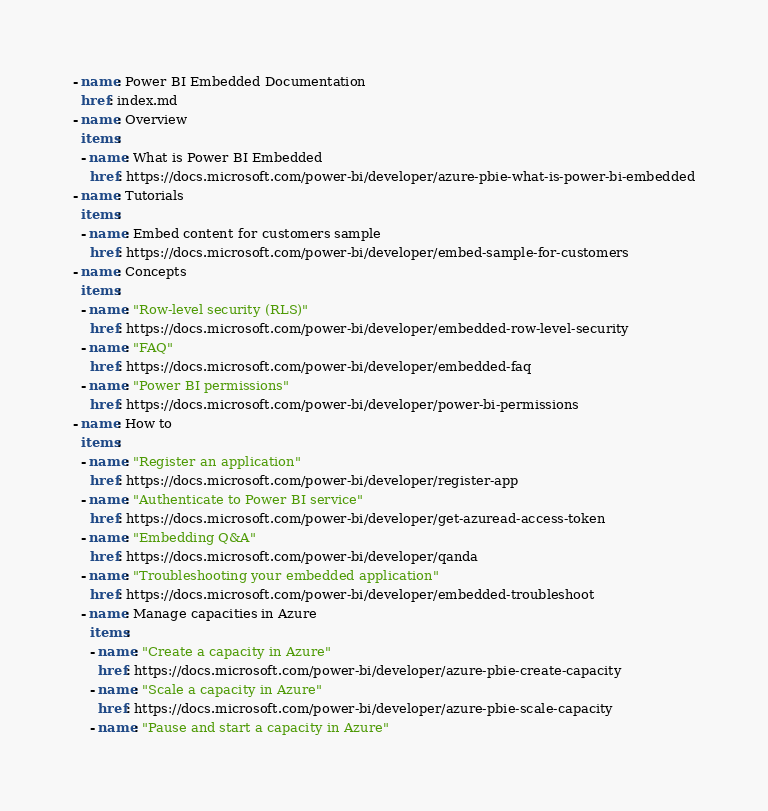Convert code to text. <code><loc_0><loc_0><loc_500><loc_500><_YAML_>- name: Power BI Embedded Documentation
  href: index.md
- name: Overview
  items:
  - name: What is Power BI Embedded
    href: https://docs.microsoft.com/power-bi/developer/azure-pbie-what-is-power-bi-embedded
- name: Tutorials
  items:
  - name: Embed content for customers sample
    href: https://docs.microsoft.com/power-bi/developer/embed-sample-for-customers
- name: Concepts
  items:
  - name: "Row-level security (RLS)"
    href: https://docs.microsoft.com/power-bi/developer/embedded-row-level-security
  - name: "FAQ"
    href: https://docs.microsoft.com/power-bi/developer/embedded-faq
  - name: "Power BI permissions"
    href: https://docs.microsoft.com/power-bi/developer/power-bi-permissions
- name: How to
  items: 
  - name: "Register an application"
    href: https://docs.microsoft.com/power-bi/developer/register-app
  - name: "Authenticate to Power BI service"
    href: https://docs.microsoft.com/power-bi/developer/get-azuread-access-token
  - name: "Embedding Q&A"
    href: https://docs.microsoft.com/power-bi/developer/qanda
  - name: "Troubleshooting your embedded application"
    href: https://docs.microsoft.com/power-bi/developer/embedded-troubleshoot
  - name: Manage capacities in Azure
    items:
    - name: "Create a capacity in Azure"
      href: https://docs.microsoft.com/power-bi/developer/azure-pbie-create-capacity
    - name: "Scale a capacity in Azure"
      href: https://docs.microsoft.com/power-bi/developer/azure-pbie-scale-capacity
    - name: "Pause and start a capacity in Azure"</code> 